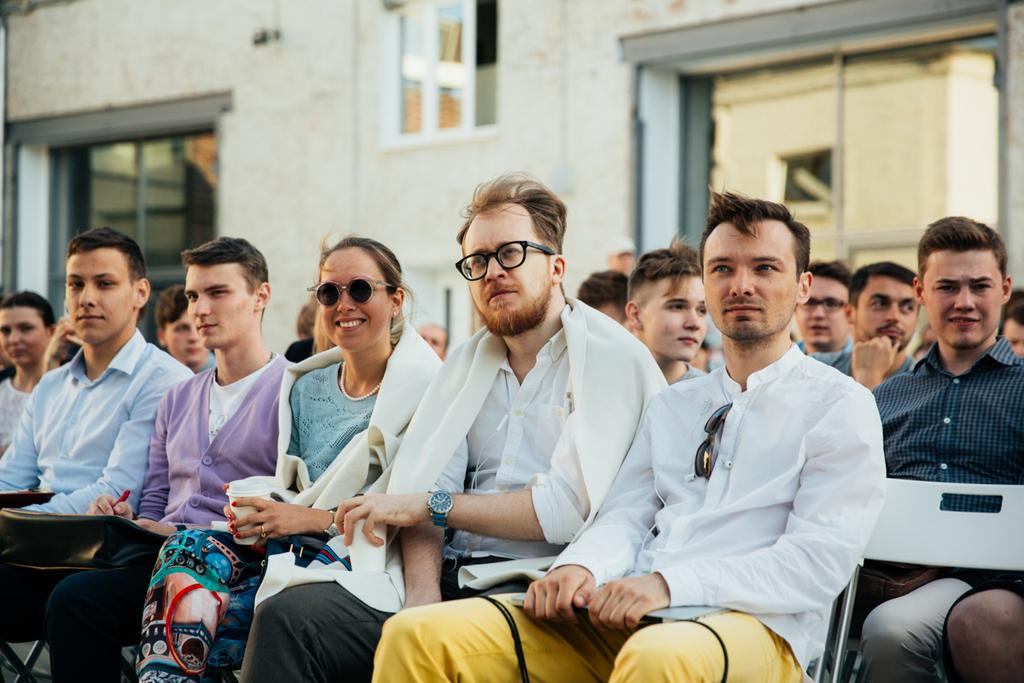What are the people in the image doing? The people in the image are sitting on chairs. What is the woman holding in the image? The woman is holding a glass in the image. What can be seen in the background of the image? There is a building in the background of the image. What type of rail can be seen connecting the chairs in the image? There is no rail connecting the chairs in the image; the people are simply sitting on them. 